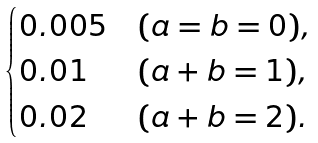Convert formula to latex. <formula><loc_0><loc_0><loc_500><loc_500>\begin{cases} 0 . 0 0 5 & ( a = b = 0 ) , \\ 0 . 0 1 & ( a + b = 1 ) , \\ 0 . 0 2 & ( a + b = 2 ) . \end{cases}</formula> 